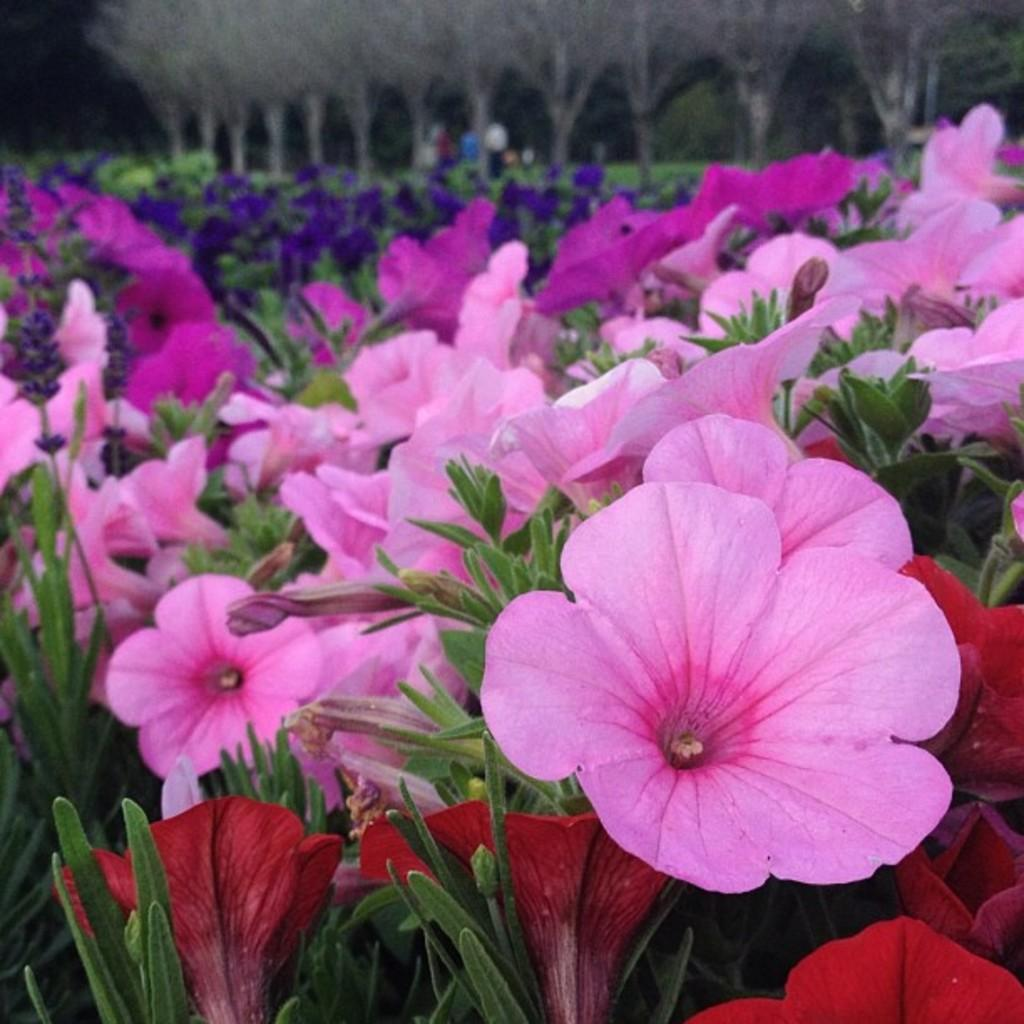What is the main subject of the image? The main subject of the image is many flowers. Can you describe the background of the image? The background of the image is blurred. What type of expert can be seen advising the tiger in the image? There is no expert or tiger present in the image; it features many flowers with a blurred background. 